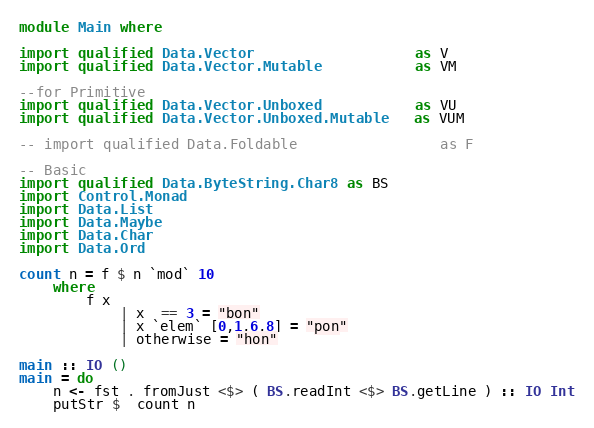Convert code to text. <code><loc_0><loc_0><loc_500><loc_500><_Haskell_>module Main where

import qualified Data.Vector                   as V
import qualified Data.Vector.Mutable           as VM

--for Primitive
import qualified Data.Vector.Unboxed           as VU
import qualified Data.Vector.Unboxed.Mutable   as VUM

-- import qualified Data.Foldable                 as F

-- Basic
import qualified Data.ByteString.Char8 as BS
import Control.Monad
import Data.List
import Data.Maybe
import Data.Char
import Data.Ord

count n = f $ n `mod` 10 
    where
        f x 
            | x  == 3 = "bon"
            | x `elem` [0,1,6,8] = "pon"
            | otherwise = "hon"

main :: IO ()
main = do
    n <- fst . fromJust <$> ( BS.readInt <$> BS.getLine ) :: IO Int
    putStr $  count n</code> 